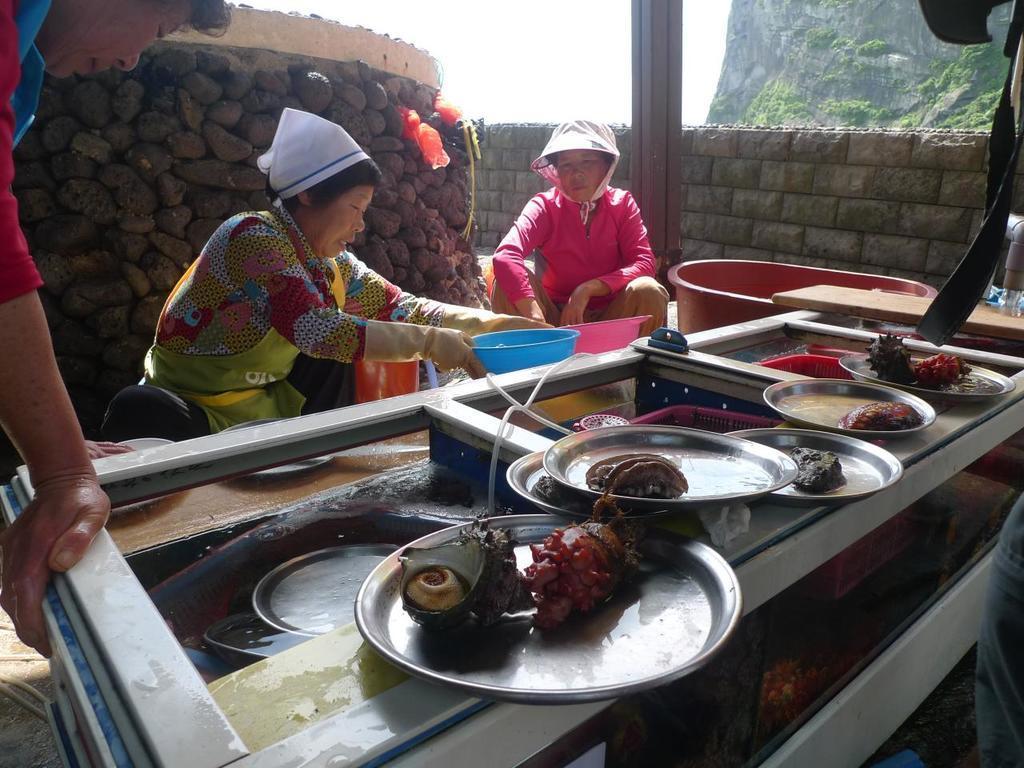Could you give a brief overview of what you see in this image? In the image we can see we can see there are people wearing clothes and two of them are holding plastic containers in their hands. Here we can see the plates and we can see the seafood on the plate. Here we can see the stone wall, pole and the sky. 